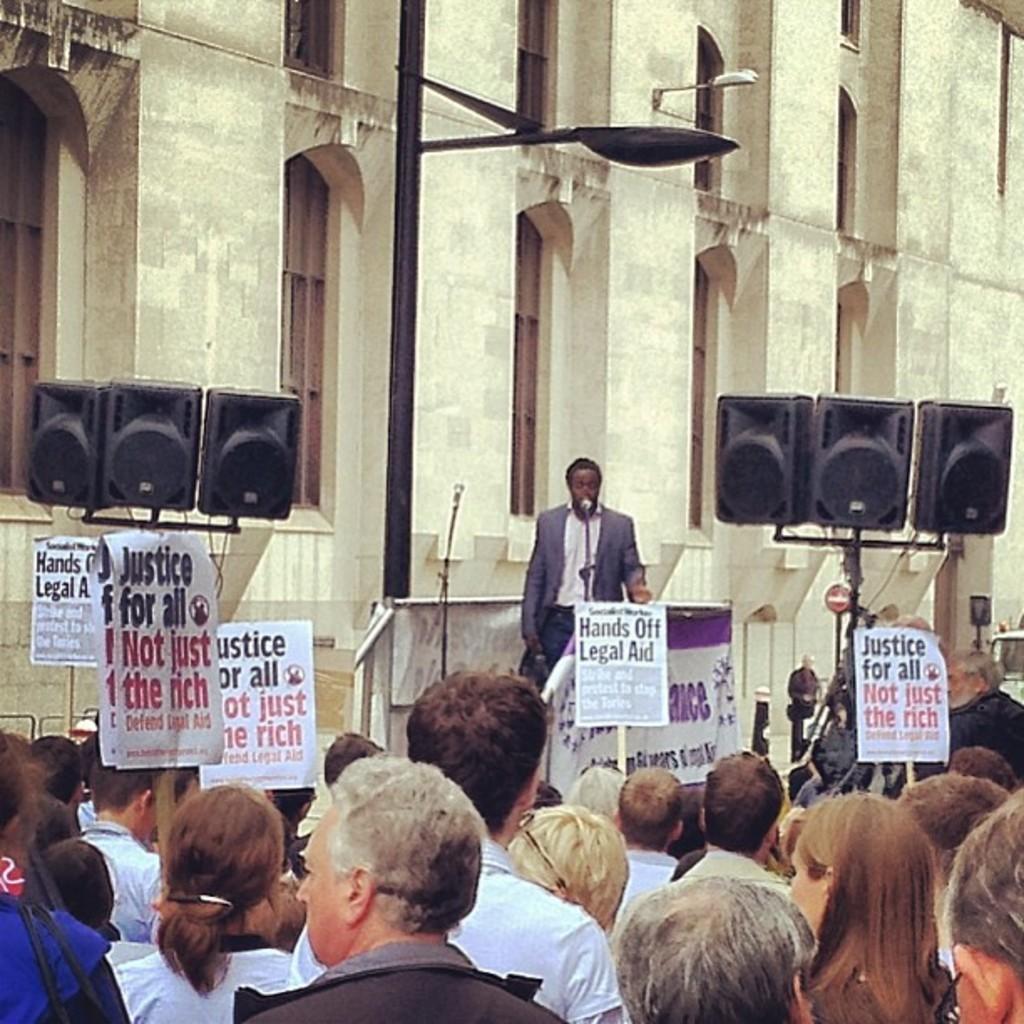Describe this image in one or two sentences. In this image we can see many people. In the background there is a building, light pole, speakers and also mike. We can also see a person standing in front of the mike. Image also consists of text papers attached to the rods. 